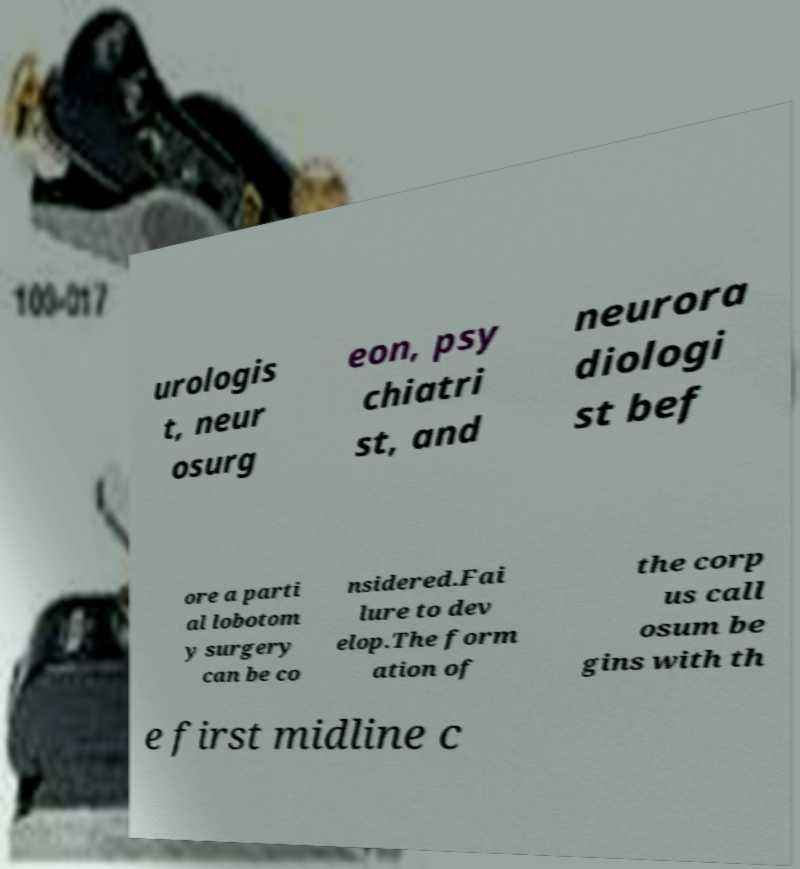What messages or text are displayed in this image? I need them in a readable, typed format. urologis t, neur osurg eon, psy chiatri st, and neurora diologi st bef ore a parti al lobotom y surgery can be co nsidered.Fai lure to dev elop.The form ation of the corp us call osum be gins with th e first midline c 